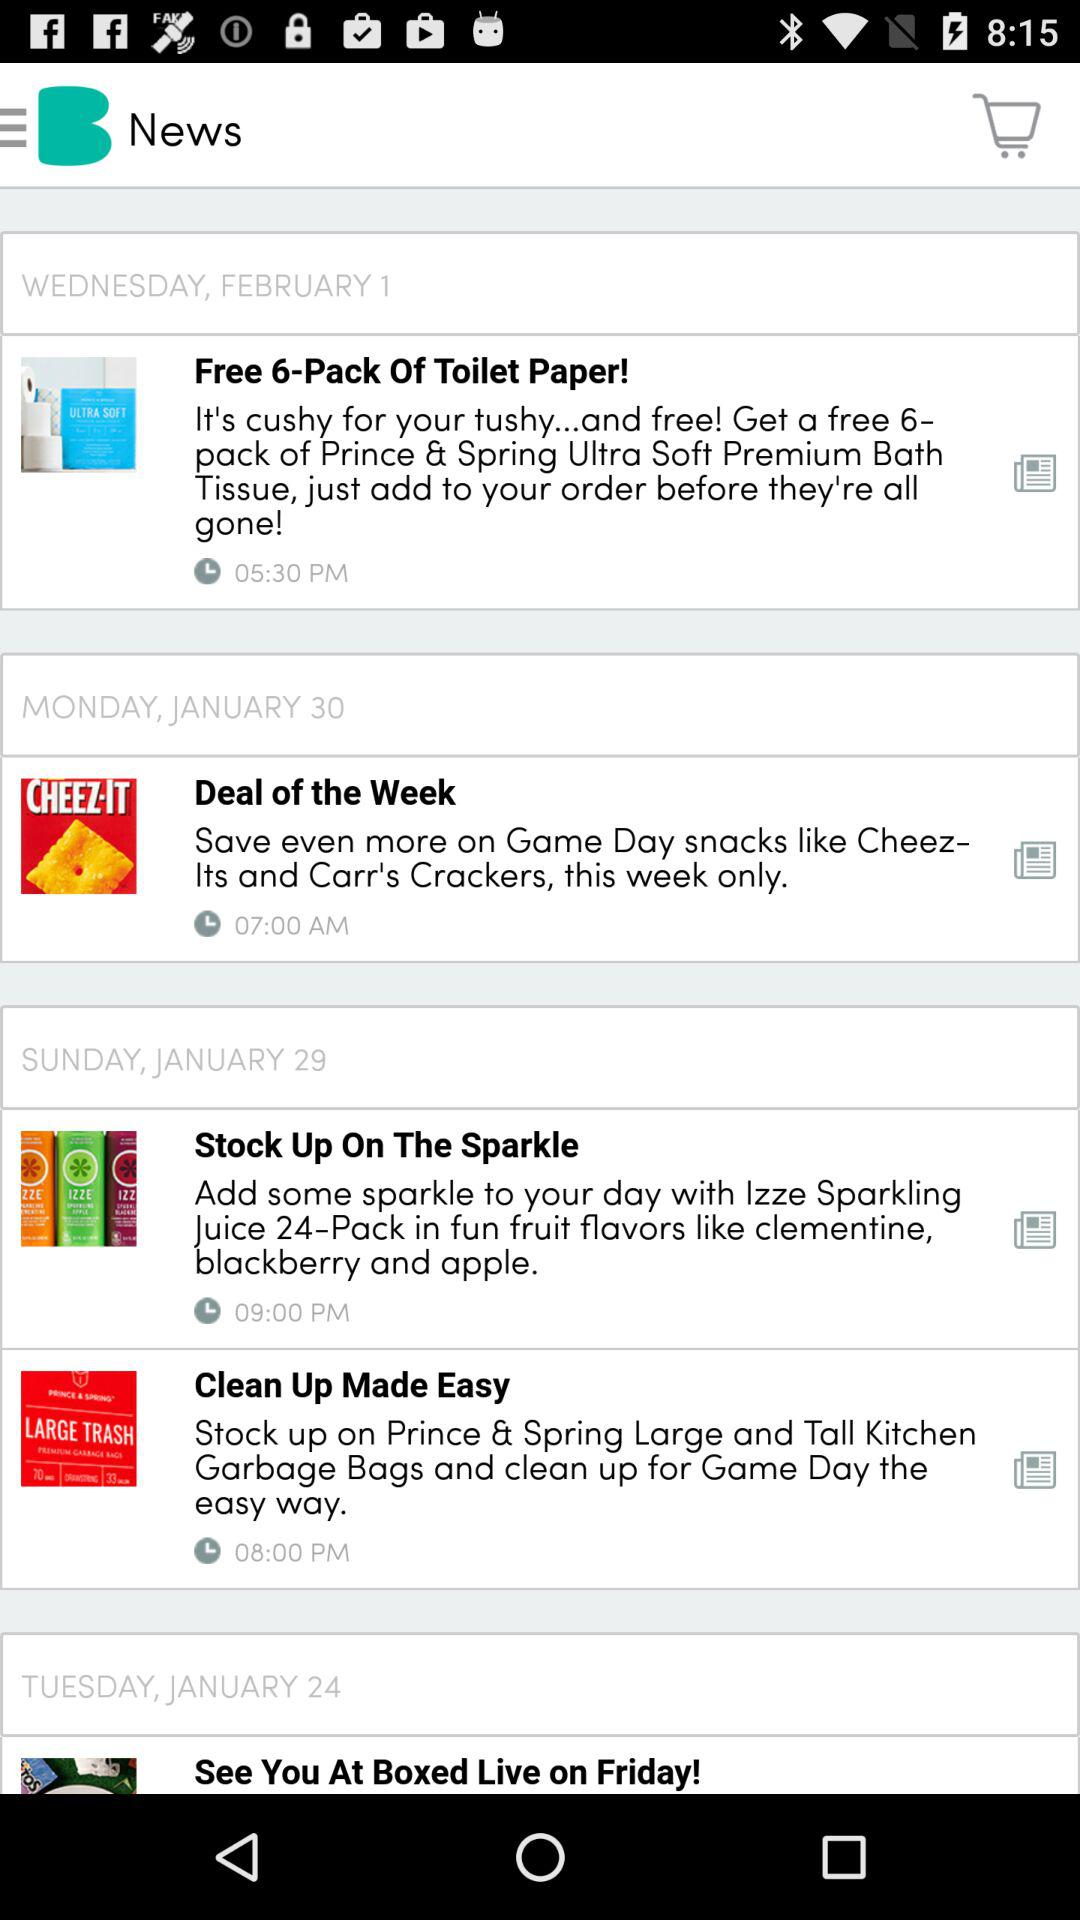What is the date of the news Stock Up On The Sparkle? The date is January 29, Sunday. 